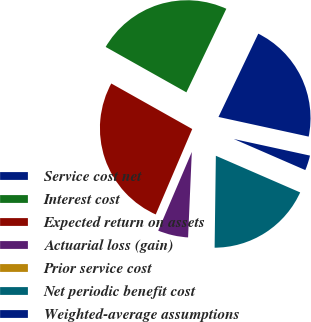Convert chart. <chart><loc_0><loc_0><loc_500><loc_500><pie_chart><fcel>Service cost net<fcel>Interest cost<fcel>Expected return on assets<fcel>Actuarial loss (gain)<fcel>Prior service cost<fcel>Net periodic benefit cost<fcel>Weighted-average assumptions<nl><fcel>21.32%<fcel>23.94%<fcel>26.73%<fcel>5.73%<fcel>0.48%<fcel>18.69%<fcel>3.11%<nl></chart> 